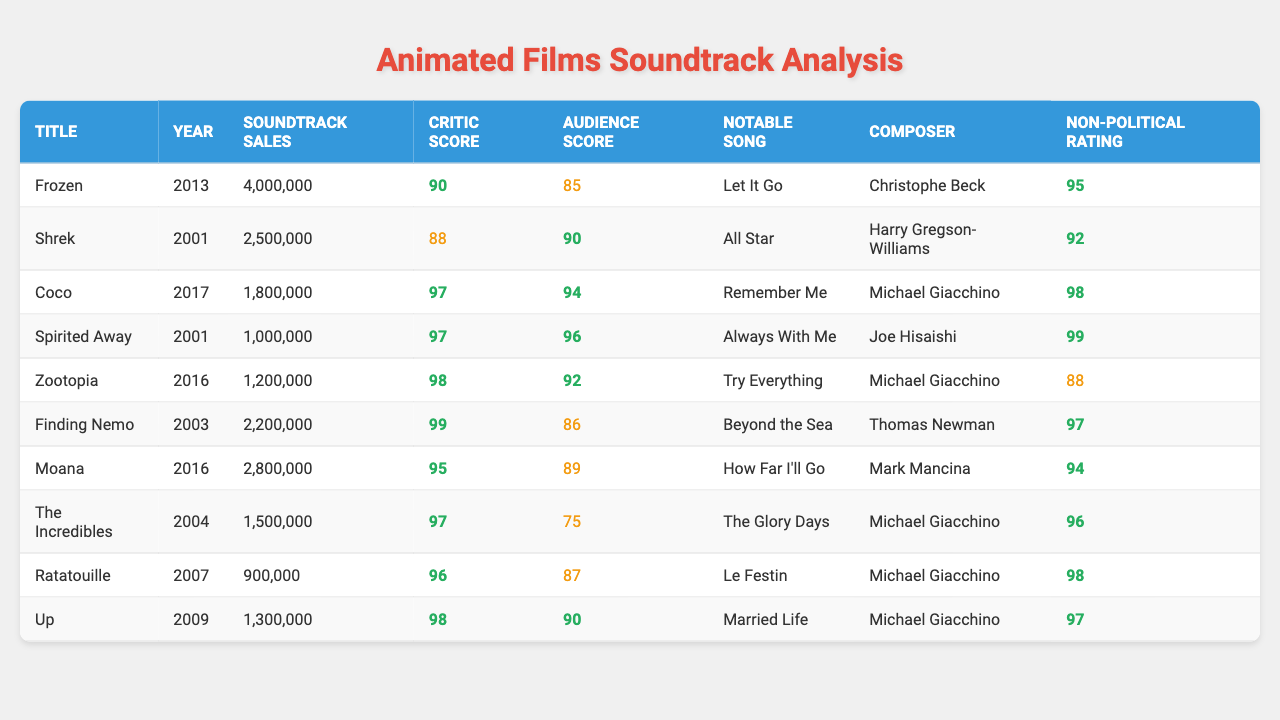What is the total number of soundtrack sales for all films listed? To find the total, add up the soundtrack sales for each film: 4,000,000 (Frozen) + 2,500,000 (Shrek) + 1,800,000 (Coco) + 1,000,000 (Spirited Away) + 1,200,000 (Zootopia) + 2,200,000 (Finding Nemo) + 2,800,000 (Moana) + 1,500,000 (The Incredibles) + 900,000 (Ratatouille) + 1,300,000 (Up) = 17,200,000.
Answer: 17,200,000 Which film has the highest critic score? The critic scores are listed next to each film. The highest score is 99 for Finding Nemo.
Answer: Finding Nemo Is there a film where the audience score is higher than the critic score? Check each film's audience score against the critic score. The Incredibles has an audience score of 75, which is lower than its critic score of 97, and the same holds for all other films. Therefore, there are no films where the audience score is higher.
Answer: No What is the average soundtrack sales for films released in the 2000s? The films from the 2000s are Shrek (2,500,000), Finding Nemo (2,200,000), The Incredibles (1,500,000), and Ratatouille (900,000). The total sales for these films is 2,500,000 + 2,200,000 + 1,500,000 + 900,000 = 7,100,000. There are 4 films, so the average is 7,100,000 / 4 = 1,775,000.
Answer: 1,775,000 What is the non-political rating of the highest-selling soundtrack? Check the soundtrack sales to find the highest, which is 4,000,000 for Frozen. Its non-political rating is 95.
Answer: 95 Which film composer is associated with "Let It Go"? The notable song "Let It Go" belongs to the film Frozen, which was composed by Christophe Beck.
Answer: Christophe Beck Which film reported the lowest soundtrack sales? Among all the films listed, Ratatouille has the lowest sales of 900,000.
Answer: Ratatouille How many films have a non-political rating of 98 or higher? Review the non-political ratings: Coco (98), Spirited Away (99), and Ratatouille (98) all have ratings of 98 or higher. There are 3 films with a rating of 98 or more.
Answer: 3 Are there any films from the year 2016 with a soundtrack sales above 1 million? Check the films from 2016: Zootopia (1,200,000) and Moana (2,800,000). Both films have soundtrack sales above 1 million.
Answer: Yes Which film has the notable song "Try Everything"? The notable song "Try Everything" is from the film Zootopia.
Answer: Zootopia 